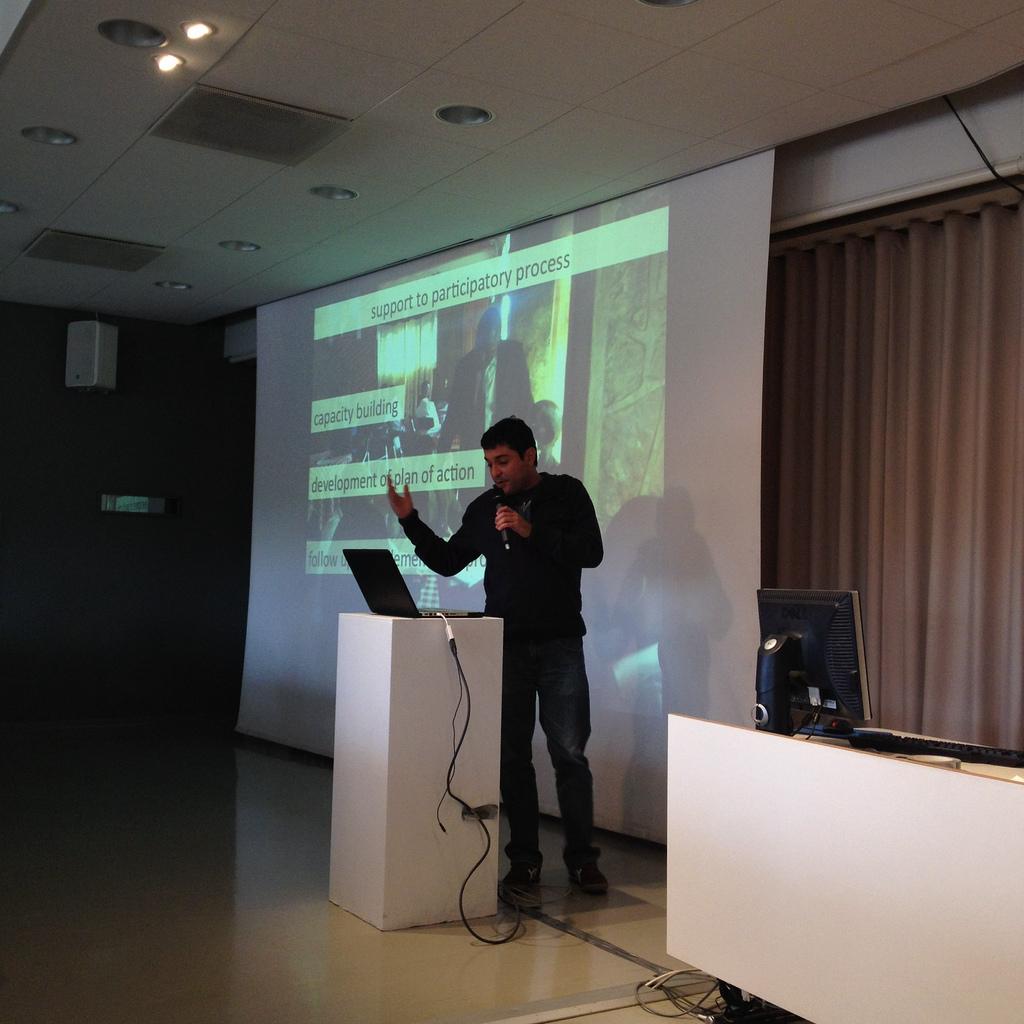What is the heading of the presentation?
Offer a very short reply. Support to participatory process. Are they going to talk about building capacity?
Provide a short and direct response. Yes. 